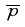<formula> <loc_0><loc_0><loc_500><loc_500>\overline { p }</formula> 